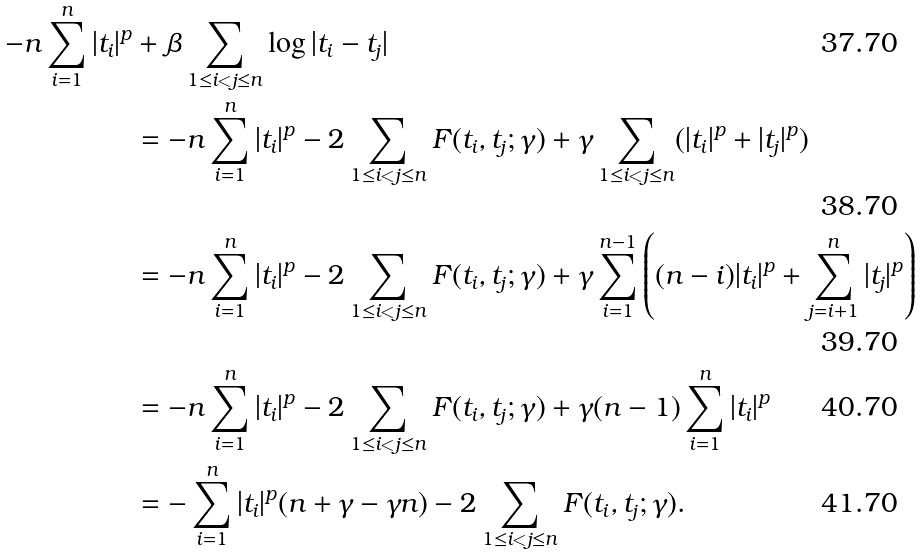Convert formula to latex. <formula><loc_0><loc_0><loc_500><loc_500>- n \sum _ { i = 1 } ^ { n } | t _ { i } | ^ { p } & + \beta \sum _ { 1 \leq i < j \leq n } \log | t _ { i } - t _ { j } | \\ & = - n \sum _ { i = 1 } ^ { n } | t _ { i } | ^ { p } - 2 \sum _ { 1 \leq i < j \leq n } F ( t _ { i } , t _ { j } ; \gamma ) + \gamma \sum _ { 1 \leq i < j \leq n } ( | t _ { i } | ^ { p } + | t _ { j } | ^ { p } ) \\ & = - n \sum _ { i = 1 } ^ { n } | t _ { i } | ^ { p } - 2 \sum _ { 1 \leq i < j \leq n } F ( t _ { i } , t _ { j } ; \gamma ) + \gamma \sum _ { i = 1 } ^ { n - 1 } \left ( ( n - i ) | t _ { i } | ^ { p } + \sum _ { j = i + 1 } ^ { n } | t _ { j } | ^ { p } \right ) \\ & = - n \sum _ { i = 1 } ^ { n } | t _ { i } | ^ { p } - 2 \sum _ { 1 \leq i < j \leq n } F ( t _ { i } , t _ { j } ; \gamma ) + \gamma ( n - 1 ) \sum _ { i = 1 } ^ { n } | t _ { i } | ^ { p } \\ & = - \sum _ { i = 1 } ^ { n } | t _ { i } | ^ { p } ( n + \gamma - \gamma n ) - 2 \sum _ { 1 \leq i < j \leq n } F ( t _ { i } , t _ { j } ; \gamma ) .</formula> 